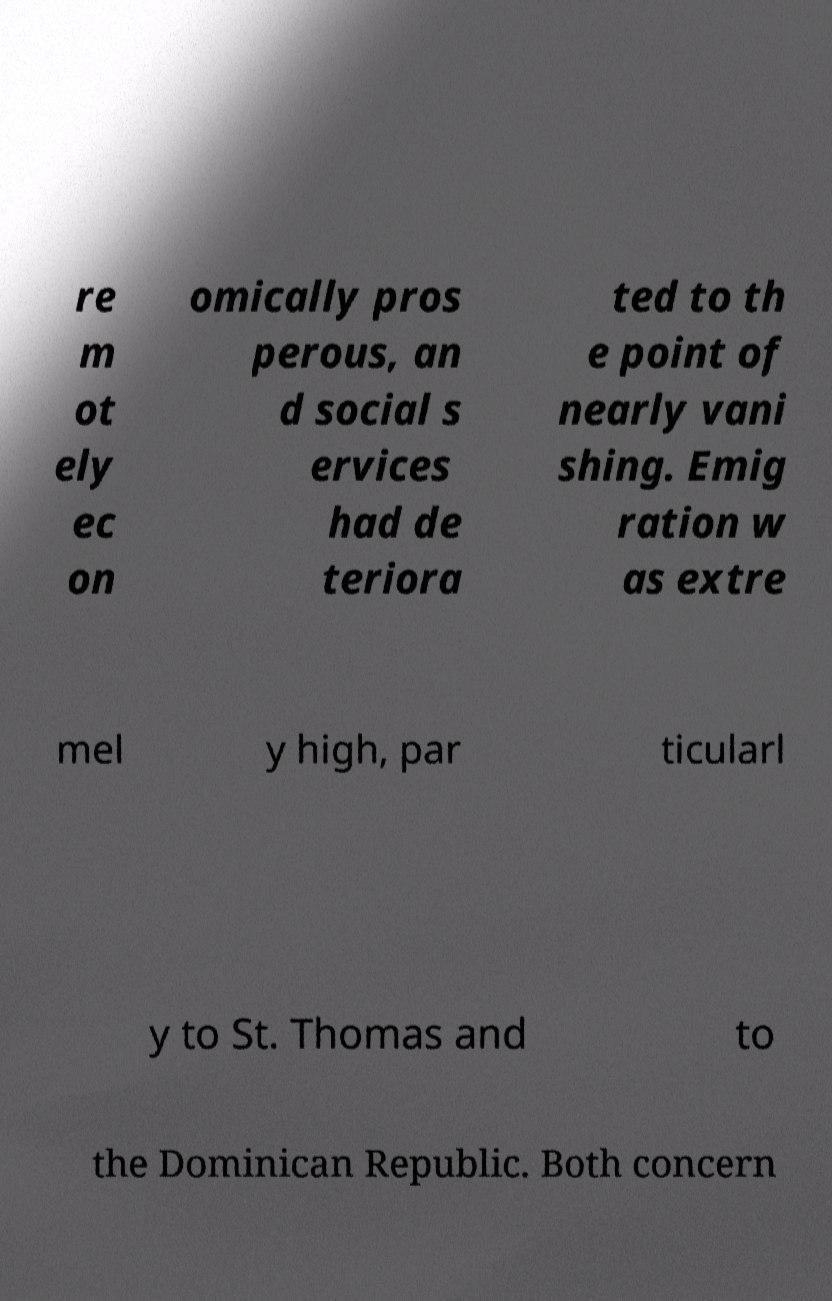Can you accurately transcribe the text from the provided image for me? re m ot ely ec on omically pros perous, an d social s ervices had de teriora ted to th e point of nearly vani shing. Emig ration w as extre mel y high, par ticularl y to St. Thomas and to the Dominican Republic. Both concern 